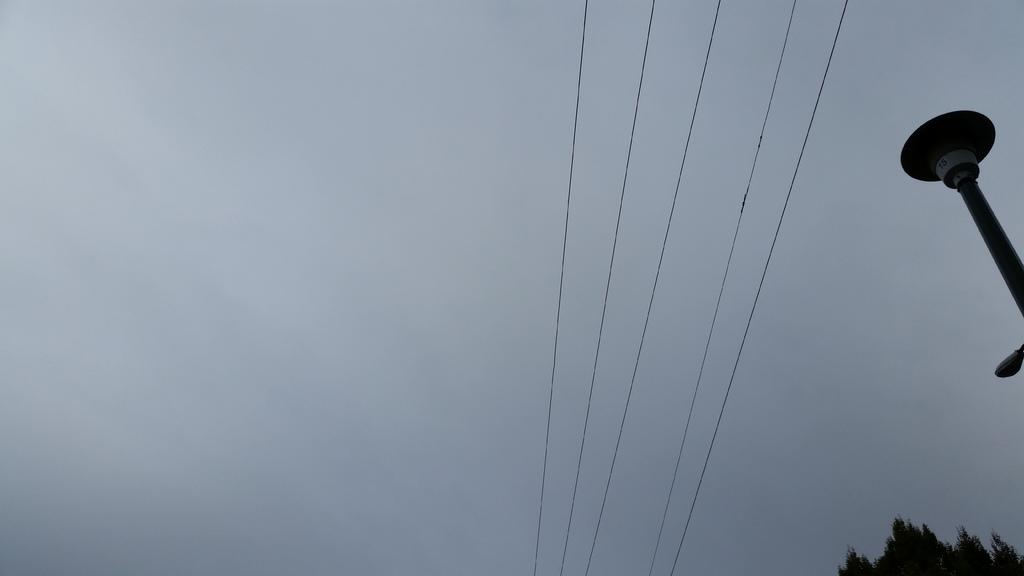Where was the picture taken? The picture was clicked outside. What can be seen on the right side of the image? There are cables and a pole, as well as a tree on the right side of the image. What is visible in the background of the image? The sky is visible in the background of the image. Can you touch the basketball in the image? There is no basketball present in the image. What time of day is it in the image? The time of day cannot be determined from the image alone, as there are no specific indicators of time. 